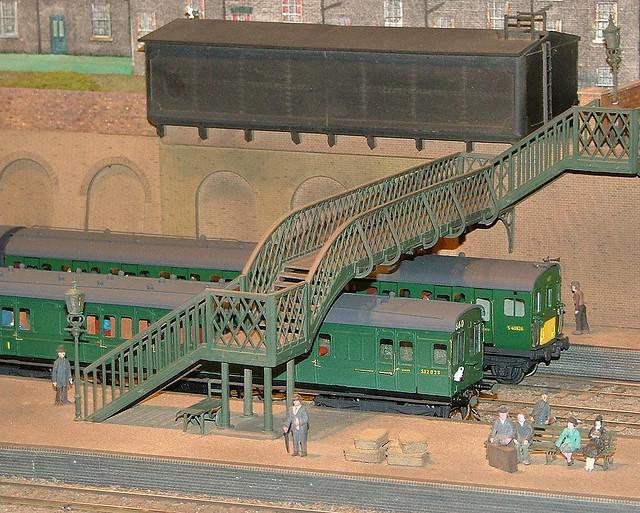What type of trains are shown here? toy trains 